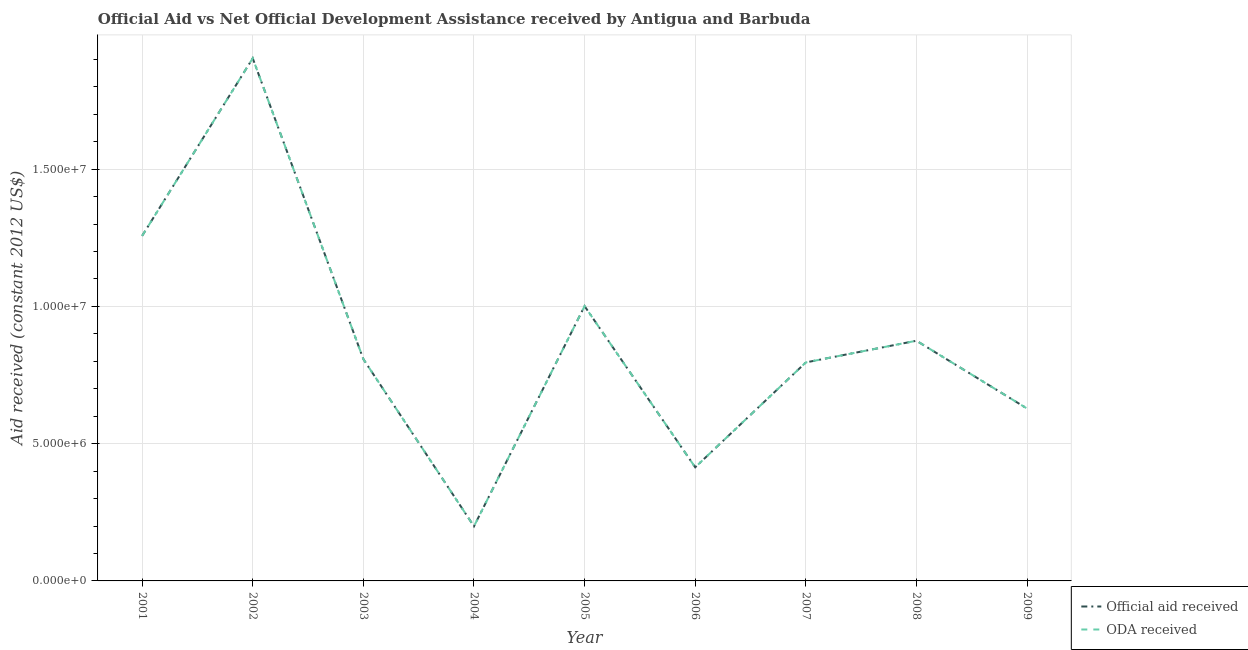How many different coloured lines are there?
Give a very brief answer. 2. What is the official aid received in 2006?
Offer a terse response. 4.14e+06. Across all years, what is the maximum oda received?
Your response must be concise. 1.90e+07. Across all years, what is the minimum oda received?
Make the answer very short. 1.99e+06. In which year was the official aid received minimum?
Your response must be concise. 2004. What is the total oda received in the graph?
Ensure brevity in your answer.  7.88e+07. What is the difference between the oda received in 2005 and that in 2006?
Your answer should be very brief. 5.87e+06. What is the difference between the oda received in 2001 and the official aid received in 2009?
Your answer should be very brief. 6.29e+06. What is the average official aid received per year?
Keep it short and to the point. 8.76e+06. In how many years, is the oda received greater than 7000000 US$?
Ensure brevity in your answer.  6. What is the ratio of the official aid received in 2002 to that in 2007?
Your response must be concise. 2.39. Is the difference between the oda received in 2008 and 2009 greater than the difference between the official aid received in 2008 and 2009?
Give a very brief answer. No. What is the difference between the highest and the second highest official aid received?
Provide a succinct answer. 6.47e+06. What is the difference between the highest and the lowest official aid received?
Give a very brief answer. 1.70e+07. In how many years, is the oda received greater than the average oda received taken over all years?
Provide a succinct answer. 3. Is the sum of the official aid received in 2006 and 2007 greater than the maximum oda received across all years?
Your response must be concise. No. Is the oda received strictly less than the official aid received over the years?
Provide a short and direct response. No. How many years are there in the graph?
Ensure brevity in your answer.  9. What is the difference between two consecutive major ticks on the Y-axis?
Make the answer very short. 5.00e+06. Are the values on the major ticks of Y-axis written in scientific E-notation?
Your response must be concise. Yes. Does the graph contain any zero values?
Ensure brevity in your answer.  No. Does the graph contain grids?
Provide a short and direct response. Yes. Where does the legend appear in the graph?
Your response must be concise. Bottom right. How many legend labels are there?
Your answer should be very brief. 2. What is the title of the graph?
Offer a terse response. Official Aid vs Net Official Development Assistance received by Antigua and Barbuda . What is the label or title of the Y-axis?
Give a very brief answer. Aid received (constant 2012 US$). What is the Aid received (constant 2012 US$) of Official aid received in 2001?
Provide a succinct answer. 1.26e+07. What is the Aid received (constant 2012 US$) in ODA received in 2001?
Provide a short and direct response. 1.26e+07. What is the Aid received (constant 2012 US$) in Official aid received in 2002?
Offer a terse response. 1.90e+07. What is the Aid received (constant 2012 US$) in ODA received in 2002?
Your answer should be very brief. 1.90e+07. What is the Aid received (constant 2012 US$) in Official aid received in 2003?
Your answer should be very brief. 8.08e+06. What is the Aid received (constant 2012 US$) of ODA received in 2003?
Provide a short and direct response. 8.08e+06. What is the Aid received (constant 2012 US$) of Official aid received in 2004?
Offer a very short reply. 1.99e+06. What is the Aid received (constant 2012 US$) of ODA received in 2004?
Provide a succinct answer. 1.99e+06. What is the Aid received (constant 2012 US$) in Official aid received in 2005?
Keep it short and to the point. 1.00e+07. What is the Aid received (constant 2012 US$) in ODA received in 2005?
Your response must be concise. 1.00e+07. What is the Aid received (constant 2012 US$) of Official aid received in 2006?
Keep it short and to the point. 4.14e+06. What is the Aid received (constant 2012 US$) of ODA received in 2006?
Offer a very short reply. 4.14e+06. What is the Aid received (constant 2012 US$) in Official aid received in 2007?
Give a very brief answer. 7.96e+06. What is the Aid received (constant 2012 US$) in ODA received in 2007?
Keep it short and to the point. 7.96e+06. What is the Aid received (constant 2012 US$) of Official aid received in 2008?
Give a very brief answer. 8.75e+06. What is the Aid received (constant 2012 US$) in ODA received in 2008?
Your answer should be very brief. 8.75e+06. What is the Aid received (constant 2012 US$) of Official aid received in 2009?
Your answer should be compact. 6.28e+06. What is the Aid received (constant 2012 US$) in ODA received in 2009?
Offer a terse response. 6.28e+06. Across all years, what is the maximum Aid received (constant 2012 US$) in Official aid received?
Keep it short and to the point. 1.90e+07. Across all years, what is the maximum Aid received (constant 2012 US$) in ODA received?
Give a very brief answer. 1.90e+07. Across all years, what is the minimum Aid received (constant 2012 US$) in Official aid received?
Keep it short and to the point. 1.99e+06. Across all years, what is the minimum Aid received (constant 2012 US$) of ODA received?
Give a very brief answer. 1.99e+06. What is the total Aid received (constant 2012 US$) in Official aid received in the graph?
Offer a very short reply. 7.88e+07. What is the total Aid received (constant 2012 US$) of ODA received in the graph?
Provide a succinct answer. 7.88e+07. What is the difference between the Aid received (constant 2012 US$) of Official aid received in 2001 and that in 2002?
Give a very brief answer. -6.47e+06. What is the difference between the Aid received (constant 2012 US$) in ODA received in 2001 and that in 2002?
Your answer should be very brief. -6.47e+06. What is the difference between the Aid received (constant 2012 US$) of Official aid received in 2001 and that in 2003?
Ensure brevity in your answer.  4.49e+06. What is the difference between the Aid received (constant 2012 US$) of ODA received in 2001 and that in 2003?
Offer a very short reply. 4.49e+06. What is the difference between the Aid received (constant 2012 US$) in Official aid received in 2001 and that in 2004?
Provide a short and direct response. 1.06e+07. What is the difference between the Aid received (constant 2012 US$) of ODA received in 2001 and that in 2004?
Provide a short and direct response. 1.06e+07. What is the difference between the Aid received (constant 2012 US$) of Official aid received in 2001 and that in 2005?
Provide a succinct answer. 2.56e+06. What is the difference between the Aid received (constant 2012 US$) of ODA received in 2001 and that in 2005?
Give a very brief answer. 2.56e+06. What is the difference between the Aid received (constant 2012 US$) in Official aid received in 2001 and that in 2006?
Ensure brevity in your answer.  8.43e+06. What is the difference between the Aid received (constant 2012 US$) in ODA received in 2001 and that in 2006?
Offer a terse response. 8.43e+06. What is the difference between the Aid received (constant 2012 US$) of Official aid received in 2001 and that in 2007?
Provide a succinct answer. 4.61e+06. What is the difference between the Aid received (constant 2012 US$) of ODA received in 2001 and that in 2007?
Your answer should be compact. 4.61e+06. What is the difference between the Aid received (constant 2012 US$) of Official aid received in 2001 and that in 2008?
Keep it short and to the point. 3.82e+06. What is the difference between the Aid received (constant 2012 US$) of ODA received in 2001 and that in 2008?
Your answer should be compact. 3.82e+06. What is the difference between the Aid received (constant 2012 US$) of Official aid received in 2001 and that in 2009?
Offer a terse response. 6.29e+06. What is the difference between the Aid received (constant 2012 US$) of ODA received in 2001 and that in 2009?
Your response must be concise. 6.29e+06. What is the difference between the Aid received (constant 2012 US$) of Official aid received in 2002 and that in 2003?
Keep it short and to the point. 1.10e+07. What is the difference between the Aid received (constant 2012 US$) of ODA received in 2002 and that in 2003?
Make the answer very short. 1.10e+07. What is the difference between the Aid received (constant 2012 US$) in Official aid received in 2002 and that in 2004?
Ensure brevity in your answer.  1.70e+07. What is the difference between the Aid received (constant 2012 US$) in ODA received in 2002 and that in 2004?
Provide a short and direct response. 1.70e+07. What is the difference between the Aid received (constant 2012 US$) in Official aid received in 2002 and that in 2005?
Keep it short and to the point. 9.03e+06. What is the difference between the Aid received (constant 2012 US$) in ODA received in 2002 and that in 2005?
Your response must be concise. 9.03e+06. What is the difference between the Aid received (constant 2012 US$) of Official aid received in 2002 and that in 2006?
Ensure brevity in your answer.  1.49e+07. What is the difference between the Aid received (constant 2012 US$) in ODA received in 2002 and that in 2006?
Give a very brief answer. 1.49e+07. What is the difference between the Aid received (constant 2012 US$) of Official aid received in 2002 and that in 2007?
Make the answer very short. 1.11e+07. What is the difference between the Aid received (constant 2012 US$) in ODA received in 2002 and that in 2007?
Ensure brevity in your answer.  1.11e+07. What is the difference between the Aid received (constant 2012 US$) in Official aid received in 2002 and that in 2008?
Provide a short and direct response. 1.03e+07. What is the difference between the Aid received (constant 2012 US$) of ODA received in 2002 and that in 2008?
Offer a very short reply. 1.03e+07. What is the difference between the Aid received (constant 2012 US$) in Official aid received in 2002 and that in 2009?
Your response must be concise. 1.28e+07. What is the difference between the Aid received (constant 2012 US$) in ODA received in 2002 and that in 2009?
Provide a short and direct response. 1.28e+07. What is the difference between the Aid received (constant 2012 US$) in Official aid received in 2003 and that in 2004?
Provide a short and direct response. 6.09e+06. What is the difference between the Aid received (constant 2012 US$) of ODA received in 2003 and that in 2004?
Offer a terse response. 6.09e+06. What is the difference between the Aid received (constant 2012 US$) in Official aid received in 2003 and that in 2005?
Offer a very short reply. -1.93e+06. What is the difference between the Aid received (constant 2012 US$) of ODA received in 2003 and that in 2005?
Your answer should be compact. -1.93e+06. What is the difference between the Aid received (constant 2012 US$) in Official aid received in 2003 and that in 2006?
Provide a short and direct response. 3.94e+06. What is the difference between the Aid received (constant 2012 US$) in ODA received in 2003 and that in 2006?
Ensure brevity in your answer.  3.94e+06. What is the difference between the Aid received (constant 2012 US$) in Official aid received in 2003 and that in 2007?
Your answer should be very brief. 1.20e+05. What is the difference between the Aid received (constant 2012 US$) of Official aid received in 2003 and that in 2008?
Your response must be concise. -6.70e+05. What is the difference between the Aid received (constant 2012 US$) of ODA received in 2003 and that in 2008?
Offer a terse response. -6.70e+05. What is the difference between the Aid received (constant 2012 US$) in Official aid received in 2003 and that in 2009?
Offer a very short reply. 1.80e+06. What is the difference between the Aid received (constant 2012 US$) in ODA received in 2003 and that in 2009?
Provide a succinct answer. 1.80e+06. What is the difference between the Aid received (constant 2012 US$) of Official aid received in 2004 and that in 2005?
Your response must be concise. -8.02e+06. What is the difference between the Aid received (constant 2012 US$) of ODA received in 2004 and that in 2005?
Keep it short and to the point. -8.02e+06. What is the difference between the Aid received (constant 2012 US$) in Official aid received in 2004 and that in 2006?
Provide a short and direct response. -2.15e+06. What is the difference between the Aid received (constant 2012 US$) of ODA received in 2004 and that in 2006?
Offer a very short reply. -2.15e+06. What is the difference between the Aid received (constant 2012 US$) of Official aid received in 2004 and that in 2007?
Offer a very short reply. -5.97e+06. What is the difference between the Aid received (constant 2012 US$) in ODA received in 2004 and that in 2007?
Provide a succinct answer. -5.97e+06. What is the difference between the Aid received (constant 2012 US$) in Official aid received in 2004 and that in 2008?
Ensure brevity in your answer.  -6.76e+06. What is the difference between the Aid received (constant 2012 US$) in ODA received in 2004 and that in 2008?
Give a very brief answer. -6.76e+06. What is the difference between the Aid received (constant 2012 US$) in Official aid received in 2004 and that in 2009?
Offer a terse response. -4.29e+06. What is the difference between the Aid received (constant 2012 US$) of ODA received in 2004 and that in 2009?
Make the answer very short. -4.29e+06. What is the difference between the Aid received (constant 2012 US$) of Official aid received in 2005 and that in 2006?
Give a very brief answer. 5.87e+06. What is the difference between the Aid received (constant 2012 US$) in ODA received in 2005 and that in 2006?
Make the answer very short. 5.87e+06. What is the difference between the Aid received (constant 2012 US$) of Official aid received in 2005 and that in 2007?
Make the answer very short. 2.05e+06. What is the difference between the Aid received (constant 2012 US$) of ODA received in 2005 and that in 2007?
Your answer should be very brief. 2.05e+06. What is the difference between the Aid received (constant 2012 US$) of Official aid received in 2005 and that in 2008?
Provide a succinct answer. 1.26e+06. What is the difference between the Aid received (constant 2012 US$) in ODA received in 2005 and that in 2008?
Your answer should be very brief. 1.26e+06. What is the difference between the Aid received (constant 2012 US$) in Official aid received in 2005 and that in 2009?
Your answer should be compact. 3.73e+06. What is the difference between the Aid received (constant 2012 US$) in ODA received in 2005 and that in 2009?
Make the answer very short. 3.73e+06. What is the difference between the Aid received (constant 2012 US$) in Official aid received in 2006 and that in 2007?
Keep it short and to the point. -3.82e+06. What is the difference between the Aid received (constant 2012 US$) in ODA received in 2006 and that in 2007?
Ensure brevity in your answer.  -3.82e+06. What is the difference between the Aid received (constant 2012 US$) of Official aid received in 2006 and that in 2008?
Provide a short and direct response. -4.61e+06. What is the difference between the Aid received (constant 2012 US$) in ODA received in 2006 and that in 2008?
Provide a short and direct response. -4.61e+06. What is the difference between the Aid received (constant 2012 US$) in Official aid received in 2006 and that in 2009?
Your answer should be compact. -2.14e+06. What is the difference between the Aid received (constant 2012 US$) in ODA received in 2006 and that in 2009?
Offer a very short reply. -2.14e+06. What is the difference between the Aid received (constant 2012 US$) of Official aid received in 2007 and that in 2008?
Offer a terse response. -7.90e+05. What is the difference between the Aid received (constant 2012 US$) of ODA received in 2007 and that in 2008?
Provide a succinct answer. -7.90e+05. What is the difference between the Aid received (constant 2012 US$) of Official aid received in 2007 and that in 2009?
Ensure brevity in your answer.  1.68e+06. What is the difference between the Aid received (constant 2012 US$) in ODA received in 2007 and that in 2009?
Your answer should be very brief. 1.68e+06. What is the difference between the Aid received (constant 2012 US$) of Official aid received in 2008 and that in 2009?
Offer a terse response. 2.47e+06. What is the difference between the Aid received (constant 2012 US$) of ODA received in 2008 and that in 2009?
Offer a very short reply. 2.47e+06. What is the difference between the Aid received (constant 2012 US$) in Official aid received in 2001 and the Aid received (constant 2012 US$) in ODA received in 2002?
Make the answer very short. -6.47e+06. What is the difference between the Aid received (constant 2012 US$) in Official aid received in 2001 and the Aid received (constant 2012 US$) in ODA received in 2003?
Ensure brevity in your answer.  4.49e+06. What is the difference between the Aid received (constant 2012 US$) of Official aid received in 2001 and the Aid received (constant 2012 US$) of ODA received in 2004?
Give a very brief answer. 1.06e+07. What is the difference between the Aid received (constant 2012 US$) in Official aid received in 2001 and the Aid received (constant 2012 US$) in ODA received in 2005?
Ensure brevity in your answer.  2.56e+06. What is the difference between the Aid received (constant 2012 US$) of Official aid received in 2001 and the Aid received (constant 2012 US$) of ODA received in 2006?
Your answer should be compact. 8.43e+06. What is the difference between the Aid received (constant 2012 US$) of Official aid received in 2001 and the Aid received (constant 2012 US$) of ODA received in 2007?
Make the answer very short. 4.61e+06. What is the difference between the Aid received (constant 2012 US$) in Official aid received in 2001 and the Aid received (constant 2012 US$) in ODA received in 2008?
Keep it short and to the point. 3.82e+06. What is the difference between the Aid received (constant 2012 US$) of Official aid received in 2001 and the Aid received (constant 2012 US$) of ODA received in 2009?
Ensure brevity in your answer.  6.29e+06. What is the difference between the Aid received (constant 2012 US$) in Official aid received in 2002 and the Aid received (constant 2012 US$) in ODA received in 2003?
Offer a very short reply. 1.10e+07. What is the difference between the Aid received (constant 2012 US$) of Official aid received in 2002 and the Aid received (constant 2012 US$) of ODA received in 2004?
Your answer should be very brief. 1.70e+07. What is the difference between the Aid received (constant 2012 US$) in Official aid received in 2002 and the Aid received (constant 2012 US$) in ODA received in 2005?
Offer a terse response. 9.03e+06. What is the difference between the Aid received (constant 2012 US$) in Official aid received in 2002 and the Aid received (constant 2012 US$) in ODA received in 2006?
Provide a short and direct response. 1.49e+07. What is the difference between the Aid received (constant 2012 US$) of Official aid received in 2002 and the Aid received (constant 2012 US$) of ODA received in 2007?
Your response must be concise. 1.11e+07. What is the difference between the Aid received (constant 2012 US$) of Official aid received in 2002 and the Aid received (constant 2012 US$) of ODA received in 2008?
Ensure brevity in your answer.  1.03e+07. What is the difference between the Aid received (constant 2012 US$) of Official aid received in 2002 and the Aid received (constant 2012 US$) of ODA received in 2009?
Keep it short and to the point. 1.28e+07. What is the difference between the Aid received (constant 2012 US$) of Official aid received in 2003 and the Aid received (constant 2012 US$) of ODA received in 2004?
Keep it short and to the point. 6.09e+06. What is the difference between the Aid received (constant 2012 US$) of Official aid received in 2003 and the Aid received (constant 2012 US$) of ODA received in 2005?
Make the answer very short. -1.93e+06. What is the difference between the Aid received (constant 2012 US$) in Official aid received in 2003 and the Aid received (constant 2012 US$) in ODA received in 2006?
Your response must be concise. 3.94e+06. What is the difference between the Aid received (constant 2012 US$) in Official aid received in 2003 and the Aid received (constant 2012 US$) in ODA received in 2008?
Provide a short and direct response. -6.70e+05. What is the difference between the Aid received (constant 2012 US$) of Official aid received in 2003 and the Aid received (constant 2012 US$) of ODA received in 2009?
Provide a succinct answer. 1.80e+06. What is the difference between the Aid received (constant 2012 US$) in Official aid received in 2004 and the Aid received (constant 2012 US$) in ODA received in 2005?
Keep it short and to the point. -8.02e+06. What is the difference between the Aid received (constant 2012 US$) of Official aid received in 2004 and the Aid received (constant 2012 US$) of ODA received in 2006?
Offer a terse response. -2.15e+06. What is the difference between the Aid received (constant 2012 US$) of Official aid received in 2004 and the Aid received (constant 2012 US$) of ODA received in 2007?
Your response must be concise. -5.97e+06. What is the difference between the Aid received (constant 2012 US$) in Official aid received in 2004 and the Aid received (constant 2012 US$) in ODA received in 2008?
Offer a very short reply. -6.76e+06. What is the difference between the Aid received (constant 2012 US$) of Official aid received in 2004 and the Aid received (constant 2012 US$) of ODA received in 2009?
Offer a very short reply. -4.29e+06. What is the difference between the Aid received (constant 2012 US$) in Official aid received in 2005 and the Aid received (constant 2012 US$) in ODA received in 2006?
Your response must be concise. 5.87e+06. What is the difference between the Aid received (constant 2012 US$) in Official aid received in 2005 and the Aid received (constant 2012 US$) in ODA received in 2007?
Give a very brief answer. 2.05e+06. What is the difference between the Aid received (constant 2012 US$) of Official aid received in 2005 and the Aid received (constant 2012 US$) of ODA received in 2008?
Provide a short and direct response. 1.26e+06. What is the difference between the Aid received (constant 2012 US$) in Official aid received in 2005 and the Aid received (constant 2012 US$) in ODA received in 2009?
Provide a succinct answer. 3.73e+06. What is the difference between the Aid received (constant 2012 US$) in Official aid received in 2006 and the Aid received (constant 2012 US$) in ODA received in 2007?
Your response must be concise. -3.82e+06. What is the difference between the Aid received (constant 2012 US$) in Official aid received in 2006 and the Aid received (constant 2012 US$) in ODA received in 2008?
Your response must be concise. -4.61e+06. What is the difference between the Aid received (constant 2012 US$) in Official aid received in 2006 and the Aid received (constant 2012 US$) in ODA received in 2009?
Your answer should be compact. -2.14e+06. What is the difference between the Aid received (constant 2012 US$) in Official aid received in 2007 and the Aid received (constant 2012 US$) in ODA received in 2008?
Provide a short and direct response. -7.90e+05. What is the difference between the Aid received (constant 2012 US$) in Official aid received in 2007 and the Aid received (constant 2012 US$) in ODA received in 2009?
Ensure brevity in your answer.  1.68e+06. What is the difference between the Aid received (constant 2012 US$) in Official aid received in 2008 and the Aid received (constant 2012 US$) in ODA received in 2009?
Provide a short and direct response. 2.47e+06. What is the average Aid received (constant 2012 US$) of Official aid received per year?
Your answer should be compact. 8.76e+06. What is the average Aid received (constant 2012 US$) of ODA received per year?
Provide a short and direct response. 8.76e+06. In the year 2002, what is the difference between the Aid received (constant 2012 US$) in Official aid received and Aid received (constant 2012 US$) in ODA received?
Your response must be concise. 0. In the year 2005, what is the difference between the Aid received (constant 2012 US$) of Official aid received and Aid received (constant 2012 US$) of ODA received?
Provide a short and direct response. 0. In the year 2007, what is the difference between the Aid received (constant 2012 US$) in Official aid received and Aid received (constant 2012 US$) in ODA received?
Offer a terse response. 0. What is the ratio of the Aid received (constant 2012 US$) of Official aid received in 2001 to that in 2002?
Provide a short and direct response. 0.66. What is the ratio of the Aid received (constant 2012 US$) of ODA received in 2001 to that in 2002?
Provide a short and direct response. 0.66. What is the ratio of the Aid received (constant 2012 US$) of Official aid received in 2001 to that in 2003?
Provide a succinct answer. 1.56. What is the ratio of the Aid received (constant 2012 US$) of ODA received in 2001 to that in 2003?
Offer a terse response. 1.56. What is the ratio of the Aid received (constant 2012 US$) of Official aid received in 2001 to that in 2004?
Keep it short and to the point. 6.32. What is the ratio of the Aid received (constant 2012 US$) of ODA received in 2001 to that in 2004?
Provide a succinct answer. 6.32. What is the ratio of the Aid received (constant 2012 US$) of Official aid received in 2001 to that in 2005?
Give a very brief answer. 1.26. What is the ratio of the Aid received (constant 2012 US$) of ODA received in 2001 to that in 2005?
Your answer should be compact. 1.26. What is the ratio of the Aid received (constant 2012 US$) of Official aid received in 2001 to that in 2006?
Give a very brief answer. 3.04. What is the ratio of the Aid received (constant 2012 US$) in ODA received in 2001 to that in 2006?
Offer a very short reply. 3.04. What is the ratio of the Aid received (constant 2012 US$) of Official aid received in 2001 to that in 2007?
Keep it short and to the point. 1.58. What is the ratio of the Aid received (constant 2012 US$) of ODA received in 2001 to that in 2007?
Your response must be concise. 1.58. What is the ratio of the Aid received (constant 2012 US$) of Official aid received in 2001 to that in 2008?
Your answer should be compact. 1.44. What is the ratio of the Aid received (constant 2012 US$) of ODA received in 2001 to that in 2008?
Give a very brief answer. 1.44. What is the ratio of the Aid received (constant 2012 US$) of Official aid received in 2001 to that in 2009?
Provide a short and direct response. 2. What is the ratio of the Aid received (constant 2012 US$) in ODA received in 2001 to that in 2009?
Keep it short and to the point. 2. What is the ratio of the Aid received (constant 2012 US$) of Official aid received in 2002 to that in 2003?
Offer a very short reply. 2.36. What is the ratio of the Aid received (constant 2012 US$) in ODA received in 2002 to that in 2003?
Offer a very short reply. 2.36. What is the ratio of the Aid received (constant 2012 US$) in Official aid received in 2002 to that in 2004?
Provide a succinct answer. 9.57. What is the ratio of the Aid received (constant 2012 US$) in ODA received in 2002 to that in 2004?
Your response must be concise. 9.57. What is the ratio of the Aid received (constant 2012 US$) of Official aid received in 2002 to that in 2005?
Your answer should be very brief. 1.9. What is the ratio of the Aid received (constant 2012 US$) in ODA received in 2002 to that in 2005?
Keep it short and to the point. 1.9. What is the ratio of the Aid received (constant 2012 US$) of Official aid received in 2002 to that in 2006?
Your answer should be very brief. 4.6. What is the ratio of the Aid received (constant 2012 US$) in ODA received in 2002 to that in 2006?
Your answer should be compact. 4.6. What is the ratio of the Aid received (constant 2012 US$) of Official aid received in 2002 to that in 2007?
Offer a terse response. 2.39. What is the ratio of the Aid received (constant 2012 US$) in ODA received in 2002 to that in 2007?
Ensure brevity in your answer.  2.39. What is the ratio of the Aid received (constant 2012 US$) of Official aid received in 2002 to that in 2008?
Provide a succinct answer. 2.18. What is the ratio of the Aid received (constant 2012 US$) of ODA received in 2002 to that in 2008?
Provide a short and direct response. 2.18. What is the ratio of the Aid received (constant 2012 US$) in Official aid received in 2002 to that in 2009?
Provide a short and direct response. 3.03. What is the ratio of the Aid received (constant 2012 US$) in ODA received in 2002 to that in 2009?
Make the answer very short. 3.03. What is the ratio of the Aid received (constant 2012 US$) of Official aid received in 2003 to that in 2004?
Provide a short and direct response. 4.06. What is the ratio of the Aid received (constant 2012 US$) in ODA received in 2003 to that in 2004?
Ensure brevity in your answer.  4.06. What is the ratio of the Aid received (constant 2012 US$) of Official aid received in 2003 to that in 2005?
Keep it short and to the point. 0.81. What is the ratio of the Aid received (constant 2012 US$) in ODA received in 2003 to that in 2005?
Make the answer very short. 0.81. What is the ratio of the Aid received (constant 2012 US$) in Official aid received in 2003 to that in 2006?
Your response must be concise. 1.95. What is the ratio of the Aid received (constant 2012 US$) in ODA received in 2003 to that in 2006?
Keep it short and to the point. 1.95. What is the ratio of the Aid received (constant 2012 US$) in Official aid received in 2003 to that in 2007?
Keep it short and to the point. 1.02. What is the ratio of the Aid received (constant 2012 US$) in ODA received in 2003 to that in 2007?
Your answer should be compact. 1.02. What is the ratio of the Aid received (constant 2012 US$) in Official aid received in 2003 to that in 2008?
Make the answer very short. 0.92. What is the ratio of the Aid received (constant 2012 US$) of ODA received in 2003 to that in 2008?
Ensure brevity in your answer.  0.92. What is the ratio of the Aid received (constant 2012 US$) in Official aid received in 2003 to that in 2009?
Offer a very short reply. 1.29. What is the ratio of the Aid received (constant 2012 US$) of ODA received in 2003 to that in 2009?
Keep it short and to the point. 1.29. What is the ratio of the Aid received (constant 2012 US$) in Official aid received in 2004 to that in 2005?
Keep it short and to the point. 0.2. What is the ratio of the Aid received (constant 2012 US$) in ODA received in 2004 to that in 2005?
Offer a very short reply. 0.2. What is the ratio of the Aid received (constant 2012 US$) in Official aid received in 2004 to that in 2006?
Give a very brief answer. 0.48. What is the ratio of the Aid received (constant 2012 US$) of ODA received in 2004 to that in 2006?
Your answer should be compact. 0.48. What is the ratio of the Aid received (constant 2012 US$) in ODA received in 2004 to that in 2007?
Give a very brief answer. 0.25. What is the ratio of the Aid received (constant 2012 US$) of Official aid received in 2004 to that in 2008?
Ensure brevity in your answer.  0.23. What is the ratio of the Aid received (constant 2012 US$) of ODA received in 2004 to that in 2008?
Ensure brevity in your answer.  0.23. What is the ratio of the Aid received (constant 2012 US$) of Official aid received in 2004 to that in 2009?
Offer a very short reply. 0.32. What is the ratio of the Aid received (constant 2012 US$) of ODA received in 2004 to that in 2009?
Your answer should be very brief. 0.32. What is the ratio of the Aid received (constant 2012 US$) of Official aid received in 2005 to that in 2006?
Make the answer very short. 2.42. What is the ratio of the Aid received (constant 2012 US$) of ODA received in 2005 to that in 2006?
Ensure brevity in your answer.  2.42. What is the ratio of the Aid received (constant 2012 US$) in Official aid received in 2005 to that in 2007?
Your answer should be compact. 1.26. What is the ratio of the Aid received (constant 2012 US$) in ODA received in 2005 to that in 2007?
Offer a terse response. 1.26. What is the ratio of the Aid received (constant 2012 US$) of Official aid received in 2005 to that in 2008?
Give a very brief answer. 1.14. What is the ratio of the Aid received (constant 2012 US$) in ODA received in 2005 to that in 2008?
Keep it short and to the point. 1.14. What is the ratio of the Aid received (constant 2012 US$) of Official aid received in 2005 to that in 2009?
Offer a very short reply. 1.59. What is the ratio of the Aid received (constant 2012 US$) of ODA received in 2005 to that in 2009?
Offer a very short reply. 1.59. What is the ratio of the Aid received (constant 2012 US$) of Official aid received in 2006 to that in 2007?
Your answer should be compact. 0.52. What is the ratio of the Aid received (constant 2012 US$) in ODA received in 2006 to that in 2007?
Offer a terse response. 0.52. What is the ratio of the Aid received (constant 2012 US$) of Official aid received in 2006 to that in 2008?
Keep it short and to the point. 0.47. What is the ratio of the Aid received (constant 2012 US$) of ODA received in 2006 to that in 2008?
Your answer should be compact. 0.47. What is the ratio of the Aid received (constant 2012 US$) in Official aid received in 2006 to that in 2009?
Provide a succinct answer. 0.66. What is the ratio of the Aid received (constant 2012 US$) of ODA received in 2006 to that in 2009?
Your answer should be compact. 0.66. What is the ratio of the Aid received (constant 2012 US$) in Official aid received in 2007 to that in 2008?
Ensure brevity in your answer.  0.91. What is the ratio of the Aid received (constant 2012 US$) in ODA received in 2007 to that in 2008?
Ensure brevity in your answer.  0.91. What is the ratio of the Aid received (constant 2012 US$) of Official aid received in 2007 to that in 2009?
Make the answer very short. 1.27. What is the ratio of the Aid received (constant 2012 US$) in ODA received in 2007 to that in 2009?
Your response must be concise. 1.27. What is the ratio of the Aid received (constant 2012 US$) in Official aid received in 2008 to that in 2009?
Your response must be concise. 1.39. What is the ratio of the Aid received (constant 2012 US$) of ODA received in 2008 to that in 2009?
Your response must be concise. 1.39. What is the difference between the highest and the second highest Aid received (constant 2012 US$) in Official aid received?
Offer a terse response. 6.47e+06. What is the difference between the highest and the second highest Aid received (constant 2012 US$) in ODA received?
Keep it short and to the point. 6.47e+06. What is the difference between the highest and the lowest Aid received (constant 2012 US$) in Official aid received?
Provide a short and direct response. 1.70e+07. What is the difference between the highest and the lowest Aid received (constant 2012 US$) in ODA received?
Provide a short and direct response. 1.70e+07. 